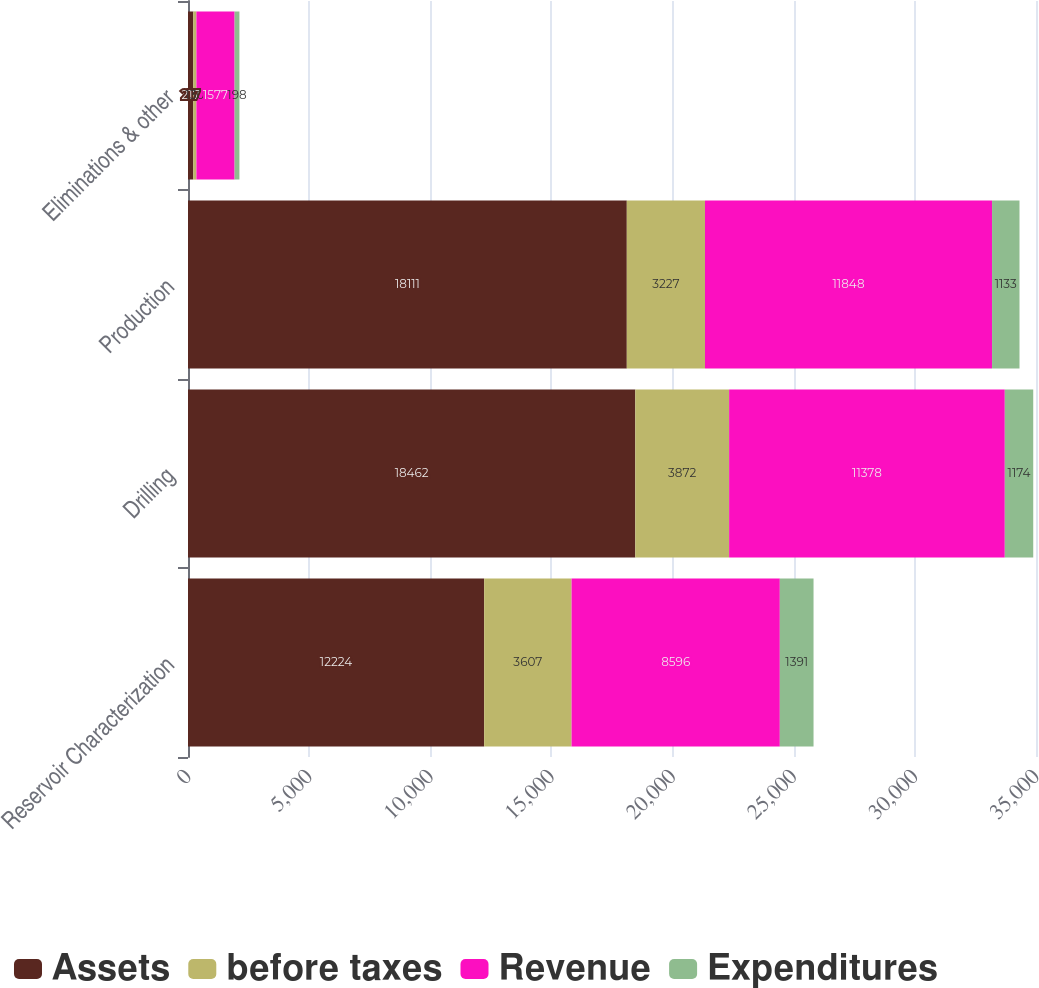Convert chart. <chart><loc_0><loc_0><loc_500><loc_500><stacked_bar_chart><ecel><fcel>Reservoir Characterization<fcel>Drilling<fcel>Production<fcel>Eliminations & other<nl><fcel>Assets<fcel>12224<fcel>18462<fcel>18111<fcel>217<nl><fcel>before taxes<fcel>3607<fcel>3872<fcel>3227<fcel>130<nl><fcel>Revenue<fcel>8596<fcel>11378<fcel>11848<fcel>1577<nl><fcel>Expenditures<fcel>1391<fcel>1174<fcel>1133<fcel>198<nl></chart> 